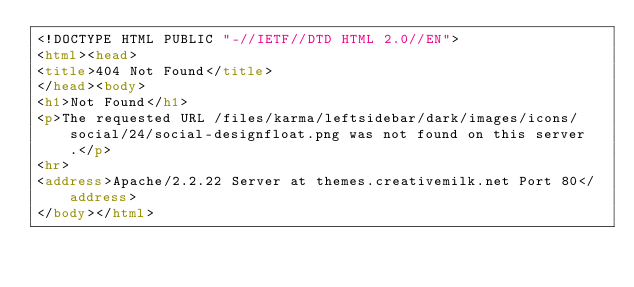Convert code to text. <code><loc_0><loc_0><loc_500><loc_500><_HTML_><!DOCTYPE HTML PUBLIC "-//IETF//DTD HTML 2.0//EN">
<html><head>
<title>404 Not Found</title>
</head><body>
<h1>Not Found</h1>
<p>The requested URL /files/karma/leftsidebar/dark/images/icons/social/24/social-designfloat.png was not found on this server.</p>
<hr>
<address>Apache/2.2.22 Server at themes.creativemilk.net Port 80</address>
</body></html>
</code> 